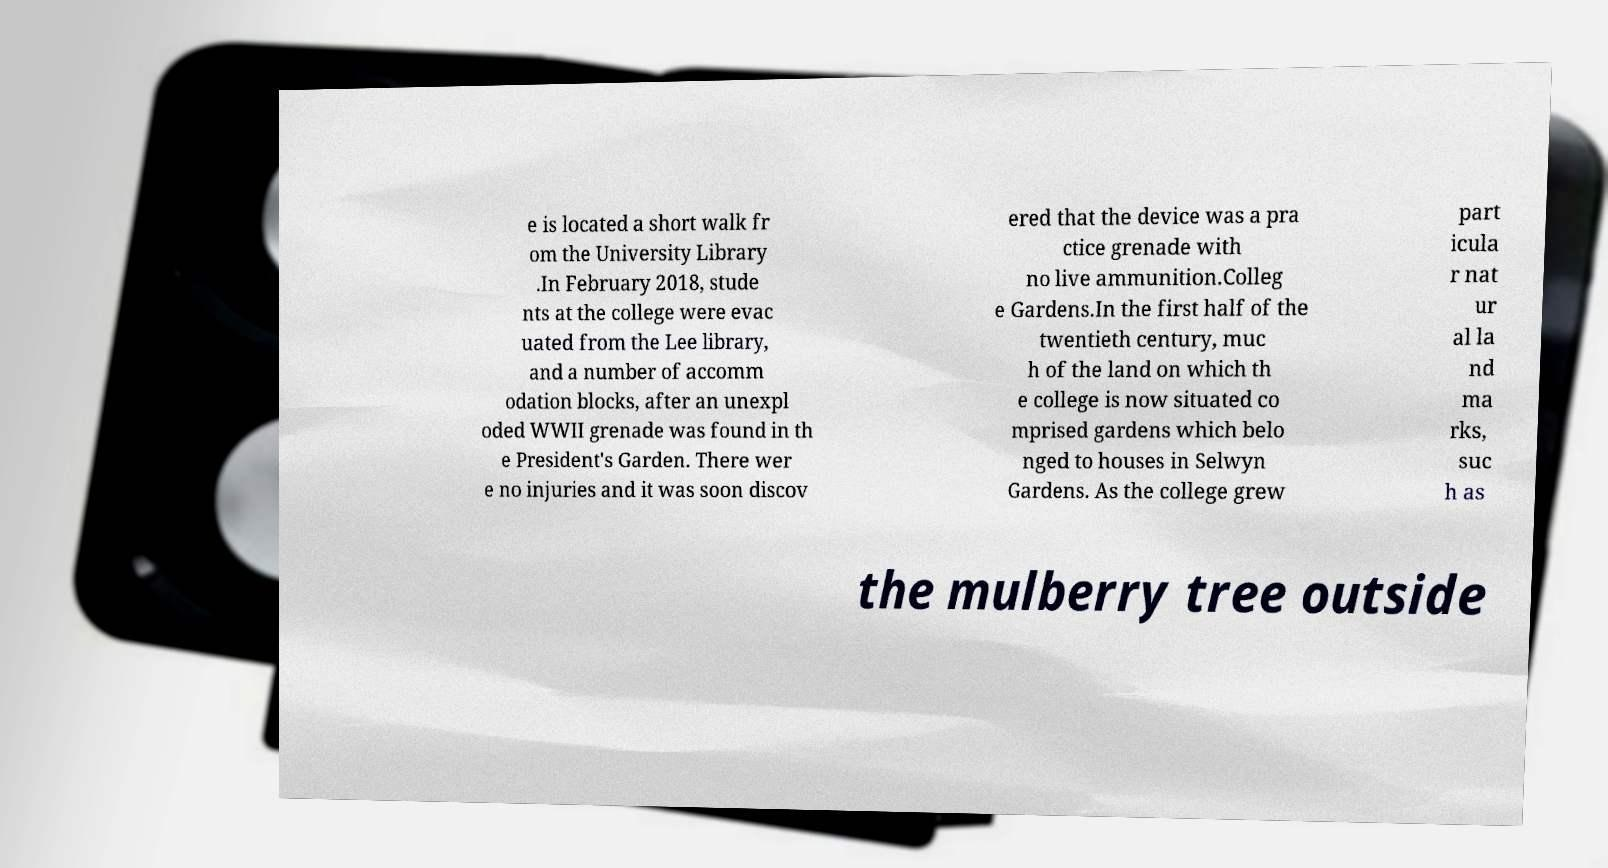Please identify and transcribe the text found in this image. e is located a short walk fr om the University Library .In February 2018, stude nts at the college were evac uated from the Lee library, and a number of accomm odation blocks, after an unexpl oded WWII grenade was found in th e President's Garden. There wer e no injuries and it was soon discov ered that the device was a pra ctice grenade with no live ammunition.Colleg e Gardens.In the first half of the twentieth century, muc h of the land on which th e college is now situated co mprised gardens which belo nged to houses in Selwyn Gardens. As the college grew part icula r nat ur al la nd ma rks, suc h as the mulberry tree outside 